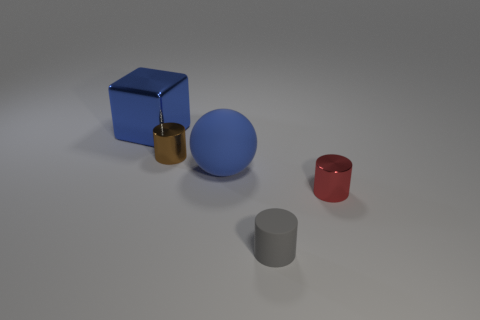How many metal cylinders are in front of the tiny cylinder that is on the left side of the blue object that is in front of the big blue metallic block?
Give a very brief answer. 1. How many gray objects are small metal objects or small rubber things?
Provide a succinct answer. 1. Do the rubber cylinder and the red cylinder that is in front of the blue block have the same size?
Your answer should be very brief. Yes. What material is the gray object that is the same shape as the tiny brown shiny thing?
Offer a very short reply. Rubber. How many other things are there of the same size as the blue matte thing?
Provide a short and direct response. 1. The big blue object that is behind the tiny metal cylinder that is to the left of the metal cylinder that is right of the tiny gray cylinder is what shape?
Make the answer very short. Cube. What shape is the shiny object that is both right of the big shiny thing and behind the red metallic cylinder?
Your answer should be compact. Cylinder. What number of things are either spheres or metal cylinders on the left side of the small red metallic thing?
Offer a terse response. 2. Do the tiny gray cylinder and the big blue sphere have the same material?
Keep it short and to the point. Yes. What number of other objects are the same shape as the blue metallic object?
Keep it short and to the point. 0. 